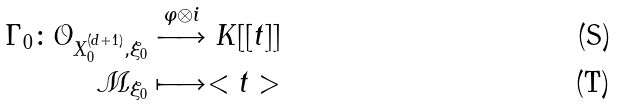<formula> <loc_0><loc_0><loc_500><loc_500>\Gamma _ { 0 } \colon \mathcal { O } _ { X _ { 0 } ^ { ( d + 1 ) } , \xi _ { 0 } } & \stackrel { \varphi \otimes i } { \longrightarrow } K [ [ t ] ] \\ \mathcal { M } _ { \xi _ { 0 } } & \longmapsto < t ></formula> 